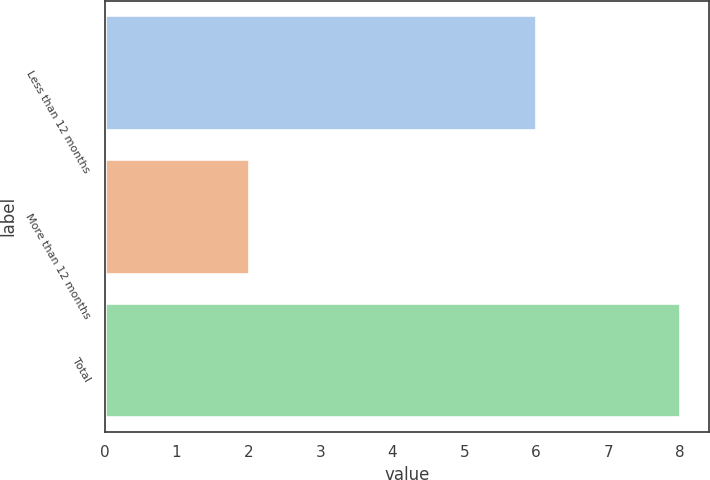Convert chart. <chart><loc_0><loc_0><loc_500><loc_500><bar_chart><fcel>Less than 12 months<fcel>More than 12 months<fcel>Total<nl><fcel>6<fcel>2<fcel>8<nl></chart> 